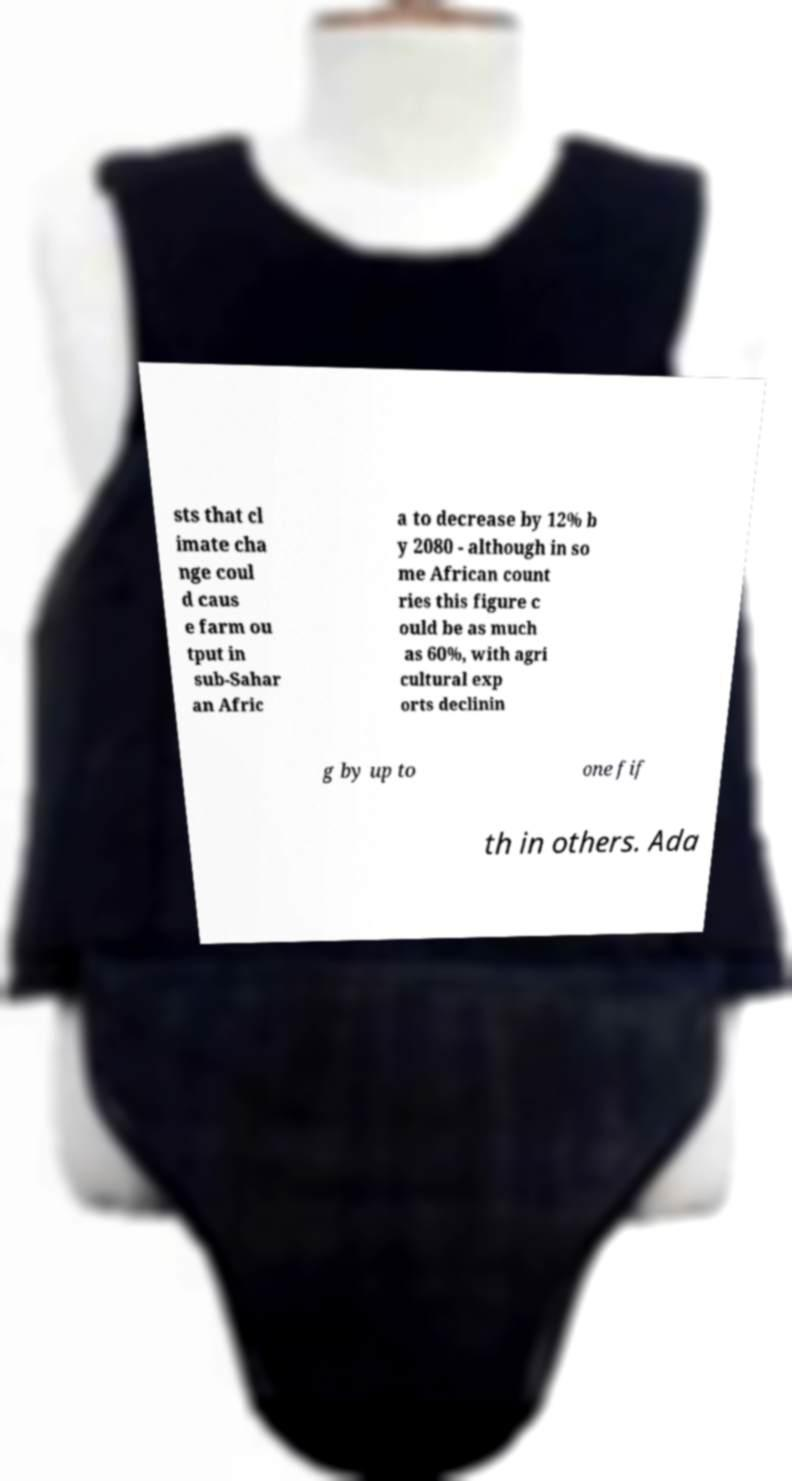What messages or text are displayed in this image? I need them in a readable, typed format. sts that cl imate cha nge coul d caus e farm ou tput in sub-Sahar an Afric a to decrease by 12% b y 2080 - although in so me African count ries this figure c ould be as much as 60%, with agri cultural exp orts declinin g by up to one fif th in others. Ada 